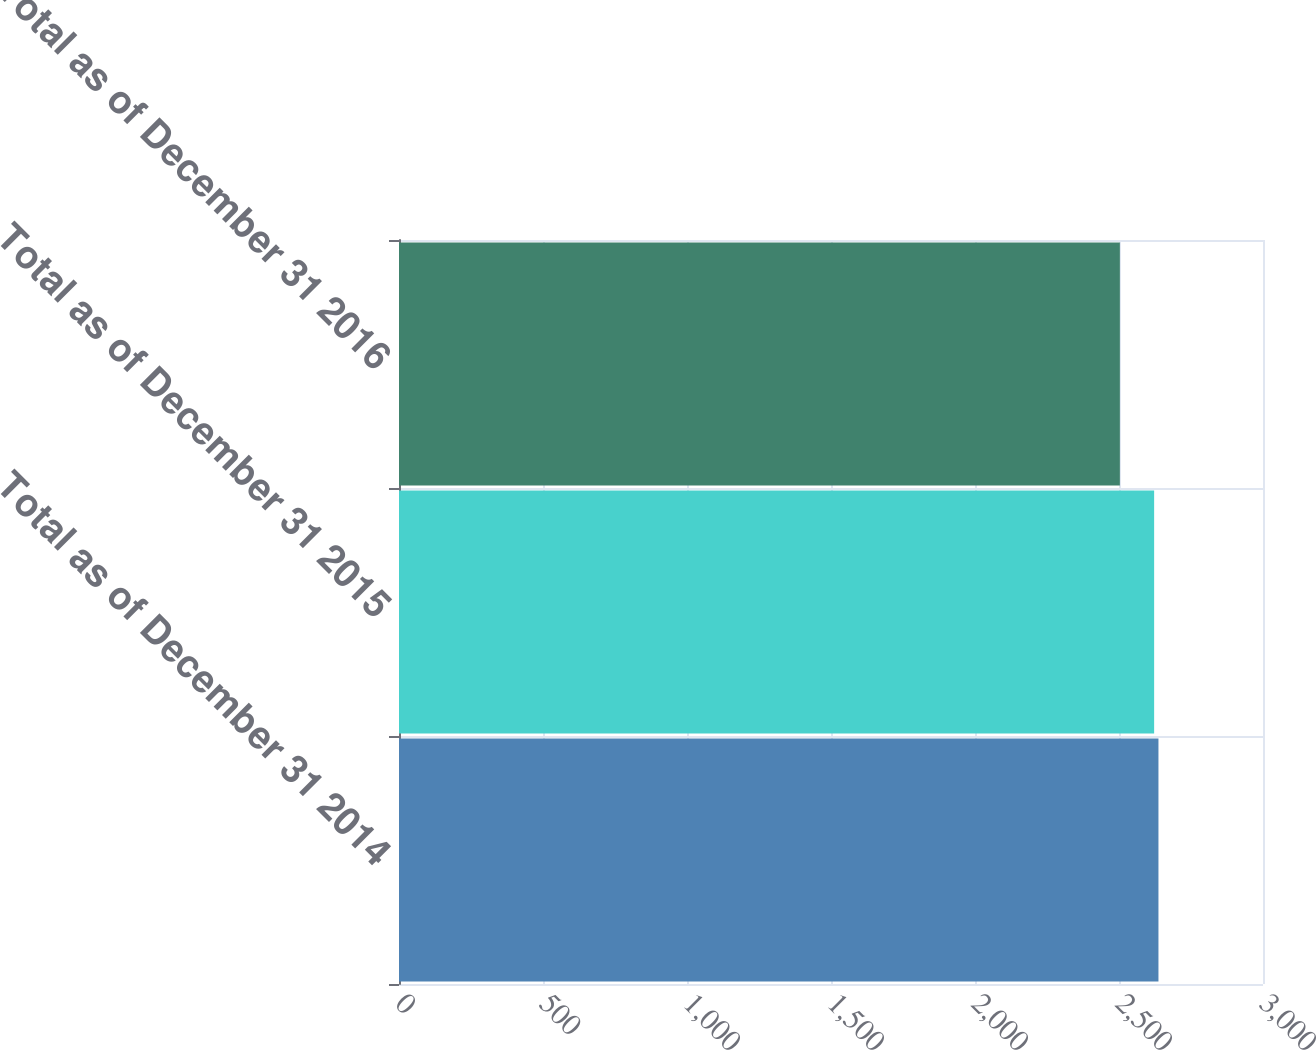<chart> <loc_0><loc_0><loc_500><loc_500><bar_chart><fcel>Total as of December 31 2014<fcel>Total as of December 31 2015<fcel>Total as of December 31 2016<nl><fcel>2637<fcel>2622<fcel>2503<nl></chart> 